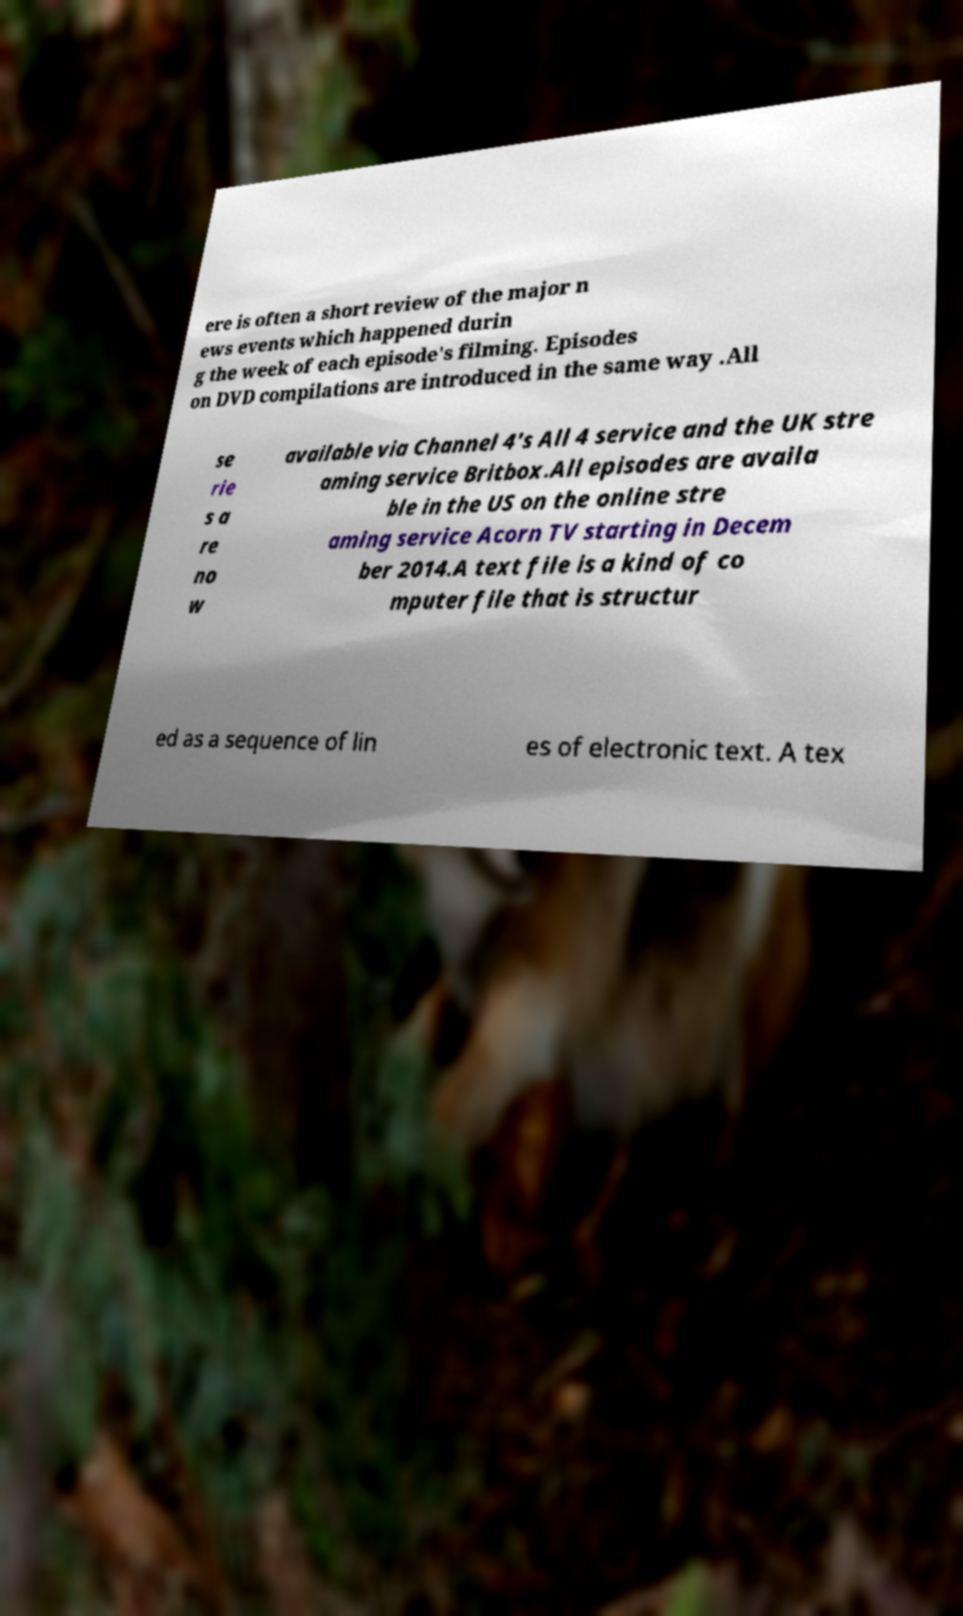Can you read and provide the text displayed in the image?This photo seems to have some interesting text. Can you extract and type it out for me? ere is often a short review of the major n ews events which happened durin g the week of each episode's filming. Episodes on DVD compilations are introduced in the same way .All se rie s a re no w available via Channel 4's All 4 service and the UK stre aming service Britbox.All episodes are availa ble in the US on the online stre aming service Acorn TV starting in Decem ber 2014.A text file is a kind of co mputer file that is structur ed as a sequence of lin es of electronic text. A tex 